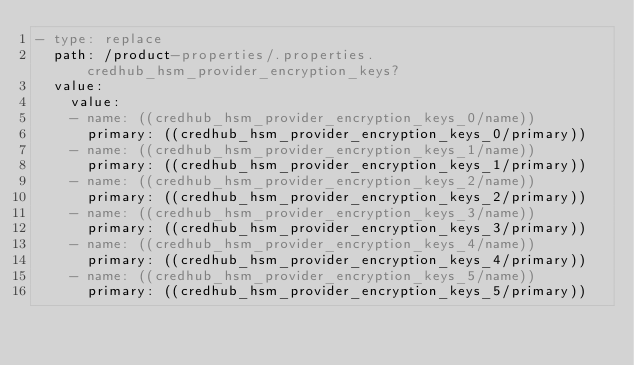Convert code to text. <code><loc_0><loc_0><loc_500><loc_500><_YAML_>- type: replace
  path: /product-properties/.properties.credhub_hsm_provider_encryption_keys?
  value:
    value:
    - name: ((credhub_hsm_provider_encryption_keys_0/name))
      primary: ((credhub_hsm_provider_encryption_keys_0/primary))
    - name: ((credhub_hsm_provider_encryption_keys_1/name))
      primary: ((credhub_hsm_provider_encryption_keys_1/primary))
    - name: ((credhub_hsm_provider_encryption_keys_2/name))
      primary: ((credhub_hsm_provider_encryption_keys_2/primary))
    - name: ((credhub_hsm_provider_encryption_keys_3/name))
      primary: ((credhub_hsm_provider_encryption_keys_3/primary))
    - name: ((credhub_hsm_provider_encryption_keys_4/name))
      primary: ((credhub_hsm_provider_encryption_keys_4/primary))
    - name: ((credhub_hsm_provider_encryption_keys_5/name))
      primary: ((credhub_hsm_provider_encryption_keys_5/primary))</code> 